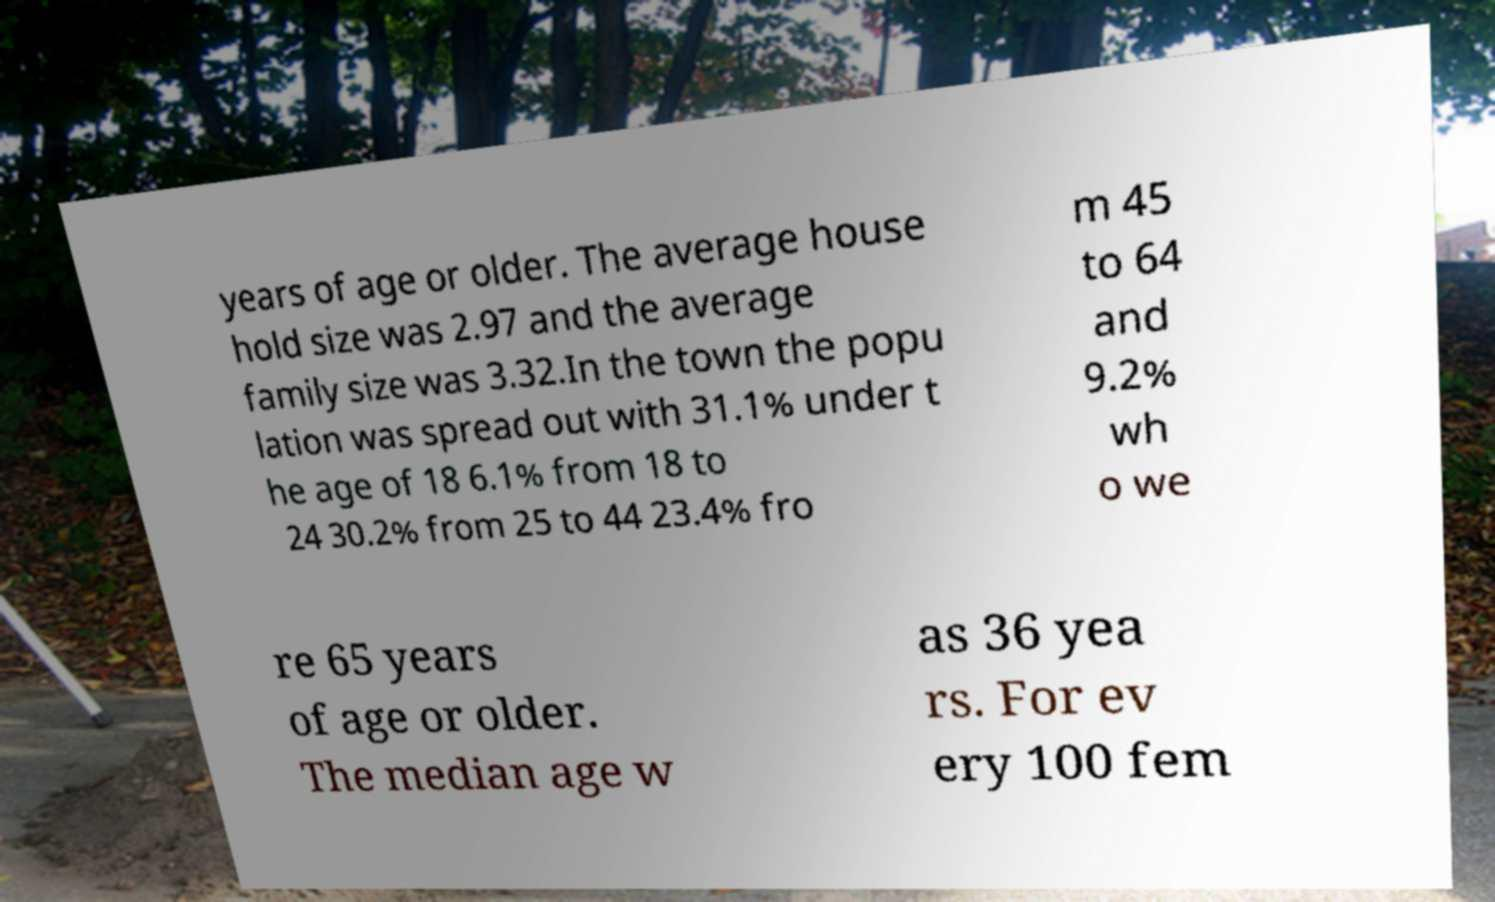Please read and relay the text visible in this image. What does it say? years of age or older. The average house hold size was 2.97 and the average family size was 3.32.In the town the popu lation was spread out with 31.1% under t he age of 18 6.1% from 18 to 24 30.2% from 25 to 44 23.4% fro m 45 to 64 and 9.2% wh o we re 65 years of age or older. The median age w as 36 yea rs. For ev ery 100 fem 